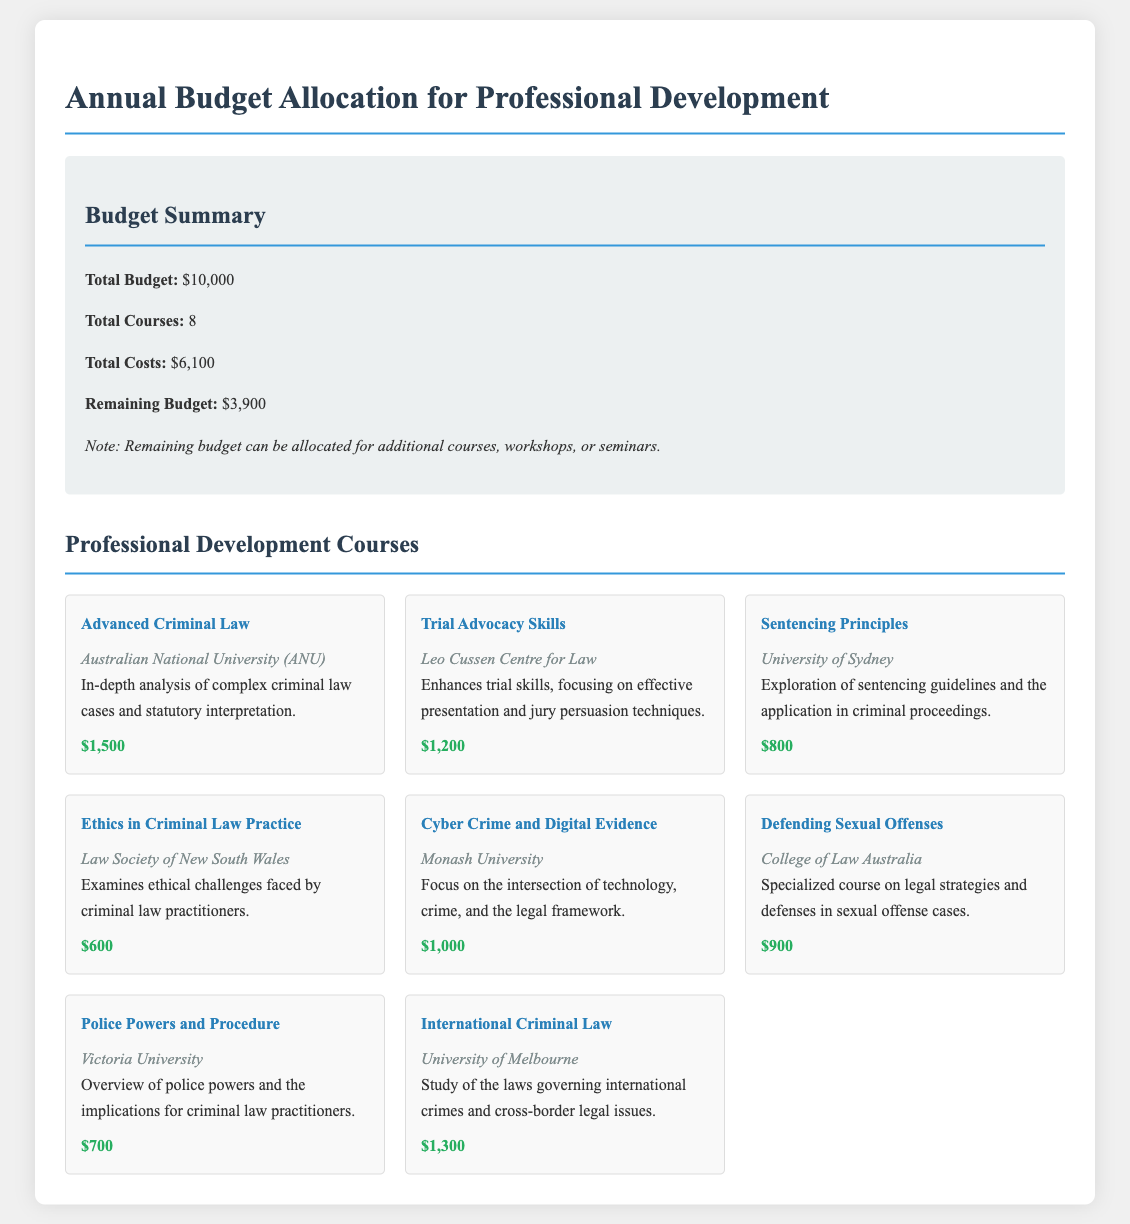What is the total budget? The total budget is specified in the budget summary of the document.
Answer: $10,000 How many courses are listed? The document states the total number of courses available for professional development.
Answer: 8 What is the cost of the "Ethics in Criminal Law Practice" course? The document provides the costs for each course, including the specified course.
Answer: $600 Which provider offers the "Defending Sexual Offenses" course? The course provider is detailed in the course listing for "Defending Sexual Offenses."
Answer: College of Law Australia What is the remaining budget after course allocations? The remaining budget is calculated as the total budget minus total costs, as indicated in the budget summary.
Answer: $3,900 Which course is the most expensive? The document lists the cost of each course, allowing for comparison to identify the most expensive one.
Answer: Advanced Criminal Law What is the total cost of all courses? The document provides the aggregated costs for all courses listed under professional development.
Answer: $6,100 What type of law does the "International Criminal Law" course pertain to? The course title indicates the focus area of the study offered in the document.
Answer: International crimes 